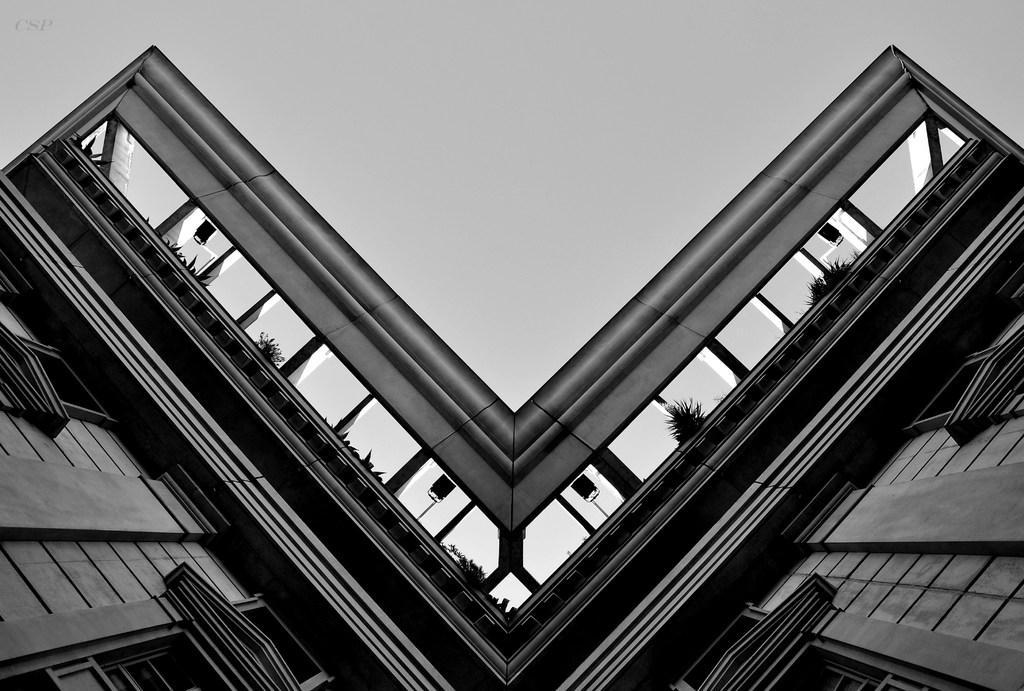In one or two sentences, can you explain what this image depicts? This is a black and white image. In this image I can see a building along with the windows. At the top of the building there are few plants. At the top of the image I can see the sky. 